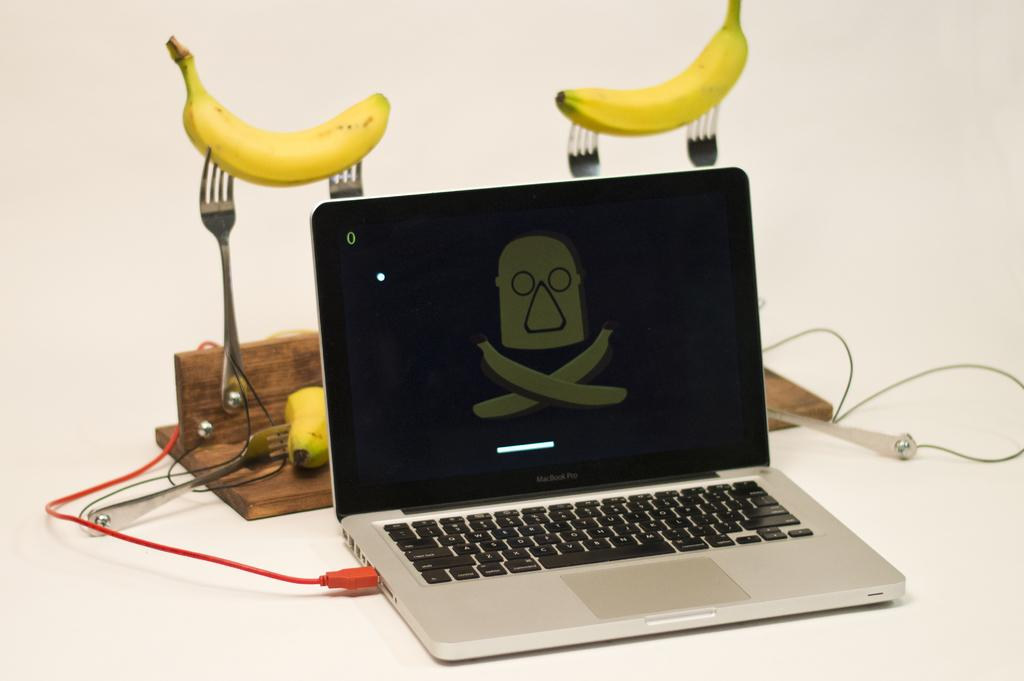What electronic device can be seen on a white surface in the image? There is a laptop on a white surface in the image. What type of fruit is present in the image? Bananas are present in the image. What utensils can be seen in the image? Forks are visible in the image. What type of object can be seen in the background of the image? There is a wooden object in the background of the image. What invention is being demonstrated by the army in the image? There is no army or invention present in the image; it features a laptop, bananas, forks, and a wooden object. 